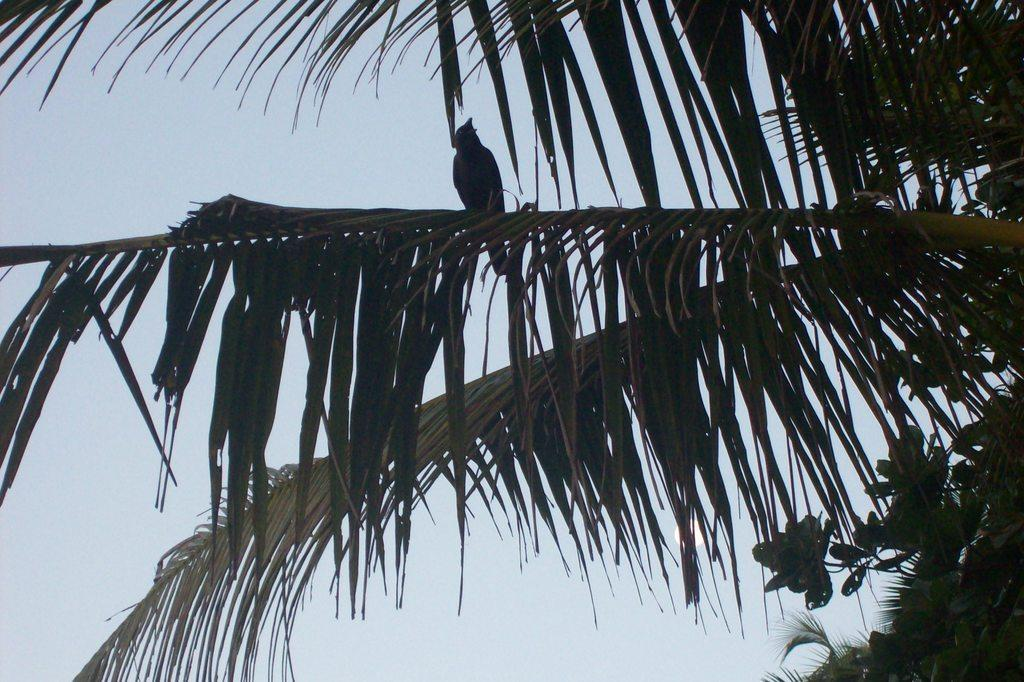What type of vegetation can be seen in the image? There are leaves in the image. What type of animal is present in the image? There is a bird in the image. Where is the bird located in the image? The bird is standing on a branch of a tree. What is the condition of the sky in the image? The sky is cloudy in the image. How many sheets are visible in the image? There are no sheets present in the image. What type of ticket can be seen in the bird's beak in the image? There is no ticket present in the image, and the bird does not have anything in its beak. 